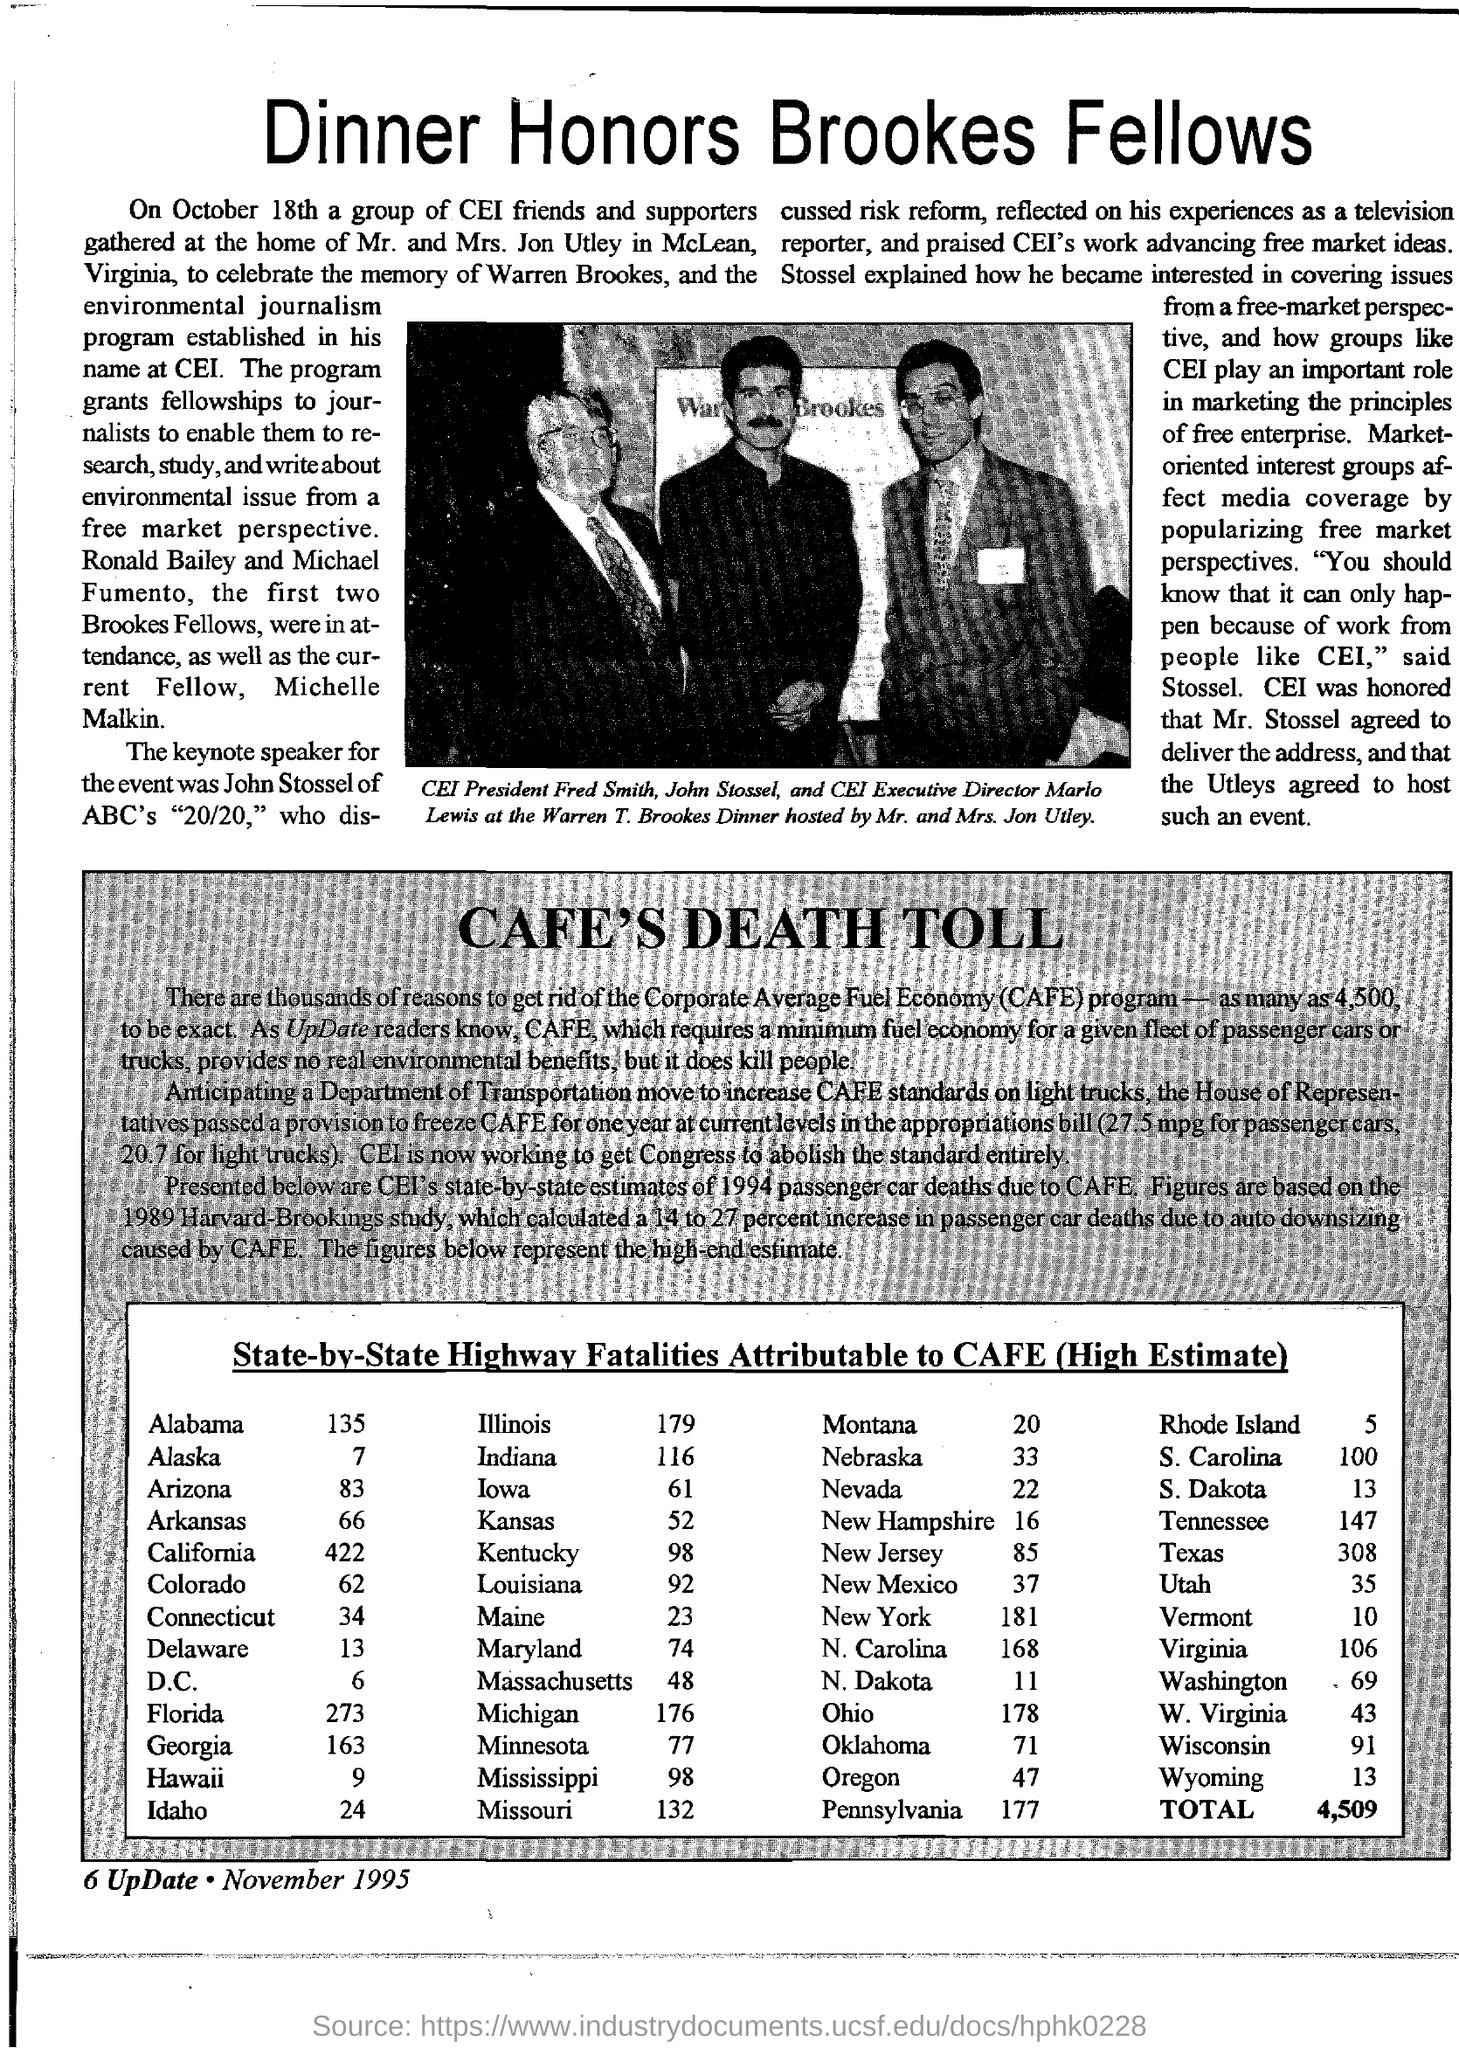Outline some significant characteristics in this image. The title of the document is "Dinner Honors Brookes Fellows. The CEI Executive Director is Marlo Lewis. The president of CEI is Fred Smith. 